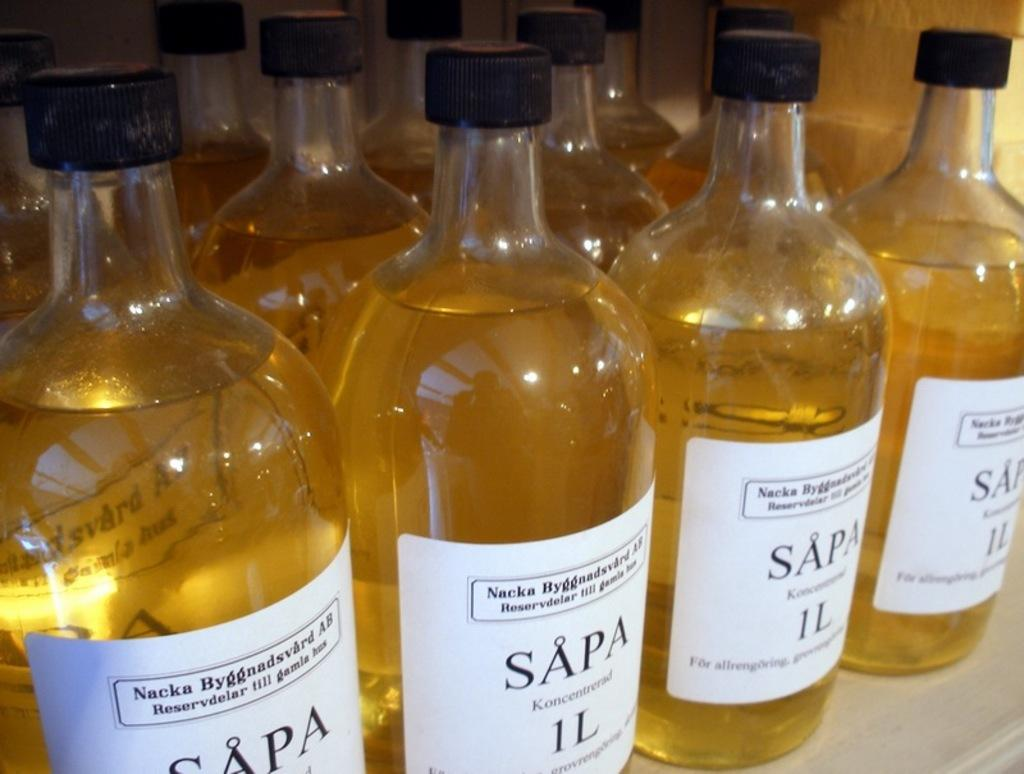Provide a one-sentence caption for the provided image. the word Sapa that is on some beer bottles. 